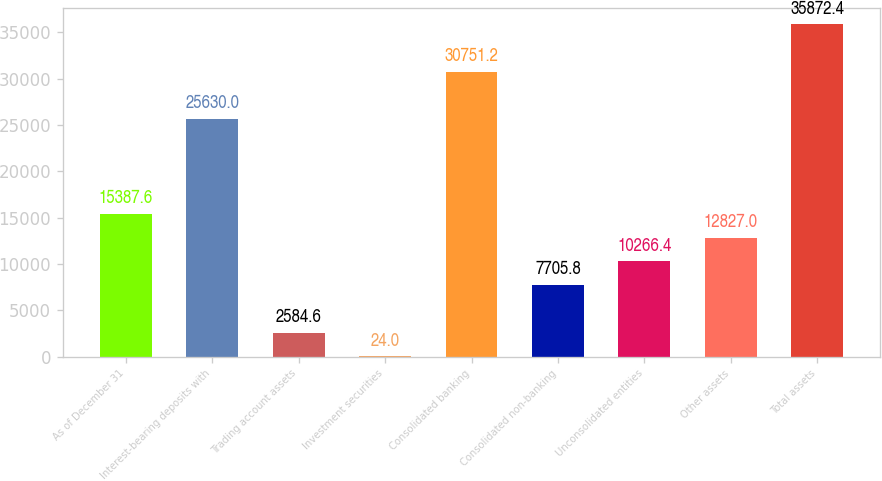Convert chart. <chart><loc_0><loc_0><loc_500><loc_500><bar_chart><fcel>As of December 31<fcel>Interest-bearing deposits with<fcel>Trading account assets<fcel>Investment securities<fcel>Consolidated banking<fcel>Consolidated non-banking<fcel>Unconsolidated entities<fcel>Other assets<fcel>Total assets<nl><fcel>15387.6<fcel>25630<fcel>2584.6<fcel>24<fcel>30751.2<fcel>7705.8<fcel>10266.4<fcel>12827<fcel>35872.4<nl></chart> 